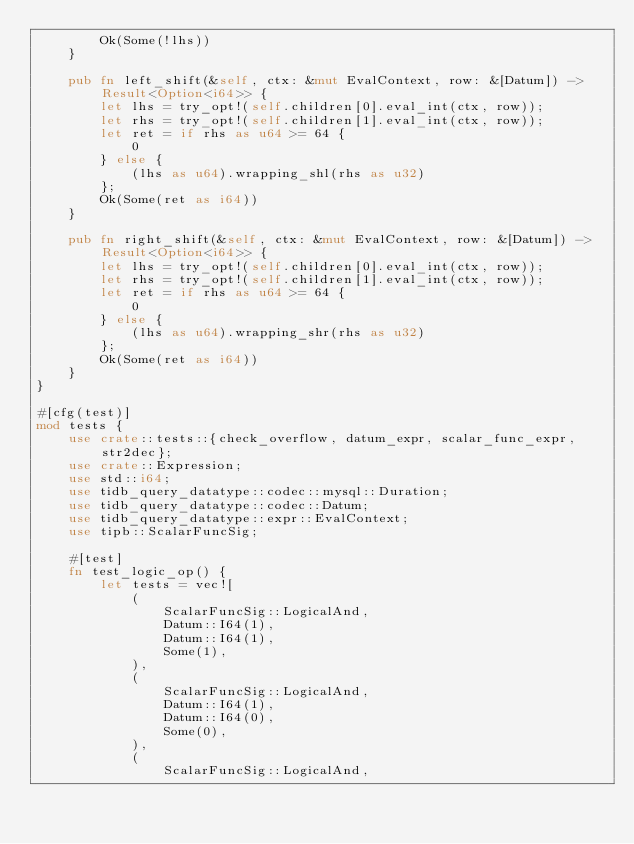Convert code to text. <code><loc_0><loc_0><loc_500><loc_500><_Rust_>        Ok(Some(!lhs))
    }

    pub fn left_shift(&self, ctx: &mut EvalContext, row: &[Datum]) -> Result<Option<i64>> {
        let lhs = try_opt!(self.children[0].eval_int(ctx, row));
        let rhs = try_opt!(self.children[1].eval_int(ctx, row));
        let ret = if rhs as u64 >= 64 {
            0
        } else {
            (lhs as u64).wrapping_shl(rhs as u32)
        };
        Ok(Some(ret as i64))
    }

    pub fn right_shift(&self, ctx: &mut EvalContext, row: &[Datum]) -> Result<Option<i64>> {
        let lhs = try_opt!(self.children[0].eval_int(ctx, row));
        let rhs = try_opt!(self.children[1].eval_int(ctx, row));
        let ret = if rhs as u64 >= 64 {
            0
        } else {
            (lhs as u64).wrapping_shr(rhs as u32)
        };
        Ok(Some(ret as i64))
    }
}

#[cfg(test)]
mod tests {
    use crate::tests::{check_overflow, datum_expr, scalar_func_expr, str2dec};
    use crate::Expression;
    use std::i64;
    use tidb_query_datatype::codec::mysql::Duration;
    use tidb_query_datatype::codec::Datum;
    use tidb_query_datatype::expr::EvalContext;
    use tipb::ScalarFuncSig;

    #[test]
    fn test_logic_op() {
        let tests = vec![
            (
                ScalarFuncSig::LogicalAnd,
                Datum::I64(1),
                Datum::I64(1),
                Some(1),
            ),
            (
                ScalarFuncSig::LogicalAnd,
                Datum::I64(1),
                Datum::I64(0),
                Some(0),
            ),
            (
                ScalarFuncSig::LogicalAnd,</code> 